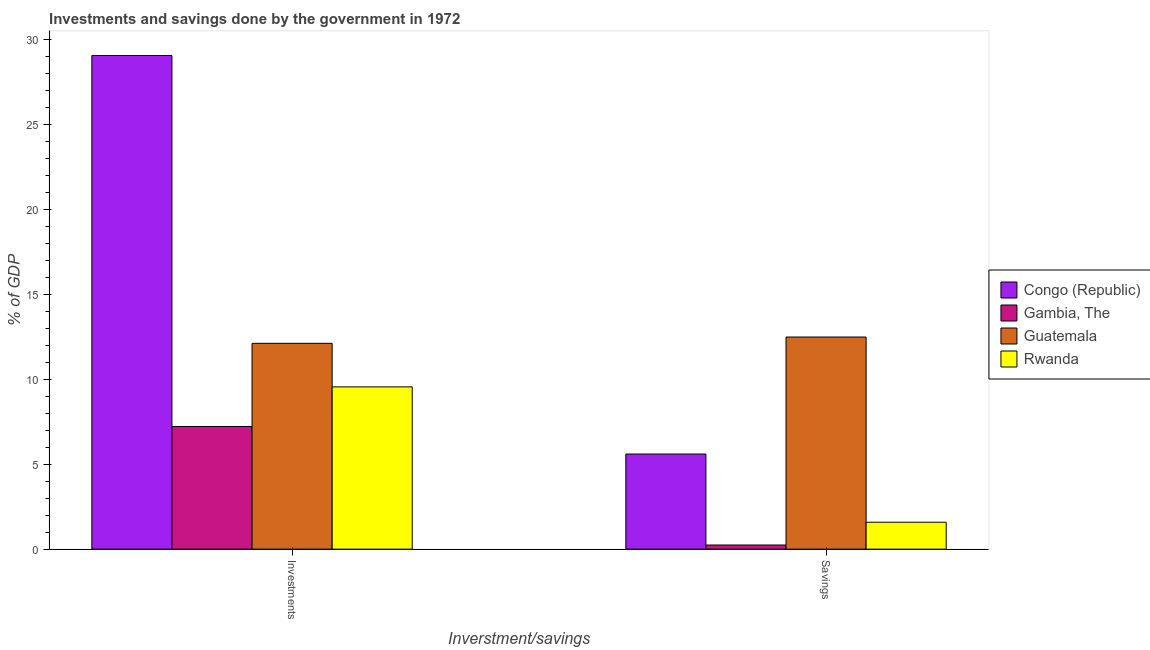How many different coloured bars are there?
Give a very brief answer. 4. How many bars are there on the 1st tick from the left?
Your answer should be very brief. 4. What is the label of the 1st group of bars from the left?
Provide a succinct answer. Investments. What is the savings of government in Gambia, The?
Offer a very short reply. 0.24. Across all countries, what is the maximum savings of government?
Your answer should be compact. 12.5. Across all countries, what is the minimum savings of government?
Keep it short and to the point. 0.24. In which country was the savings of government maximum?
Make the answer very short. Guatemala. In which country was the savings of government minimum?
Provide a succinct answer. Gambia, The. What is the total savings of government in the graph?
Make the answer very short. 19.93. What is the difference between the investments of government in Congo (Republic) and that in Guatemala?
Your answer should be compact. 16.96. What is the difference between the savings of government in Guatemala and the investments of government in Gambia, The?
Keep it short and to the point. 5.27. What is the average savings of government per country?
Make the answer very short. 4.98. What is the difference between the savings of government and investments of government in Rwanda?
Keep it short and to the point. -7.97. In how many countries, is the investments of government greater than 10 %?
Provide a short and direct response. 2. What is the ratio of the investments of government in Congo (Republic) to that in Guatemala?
Make the answer very short. 2.4. In how many countries, is the savings of government greater than the average savings of government taken over all countries?
Your response must be concise. 2. What does the 1st bar from the left in Investments represents?
Provide a succinct answer. Congo (Republic). What does the 3rd bar from the right in Investments represents?
Offer a terse response. Gambia, The. How many bars are there?
Ensure brevity in your answer.  8. How many countries are there in the graph?
Provide a short and direct response. 4. What is the difference between two consecutive major ticks on the Y-axis?
Make the answer very short. 5. Does the graph contain grids?
Offer a very short reply. No. Where does the legend appear in the graph?
Provide a succinct answer. Center right. How are the legend labels stacked?
Provide a succinct answer. Vertical. What is the title of the graph?
Provide a succinct answer. Investments and savings done by the government in 1972. Does "Small states" appear as one of the legend labels in the graph?
Your answer should be compact. No. What is the label or title of the X-axis?
Offer a terse response. Inverstment/savings. What is the label or title of the Y-axis?
Provide a succinct answer. % of GDP. What is the % of GDP of Congo (Republic) in Investments?
Keep it short and to the point. 29.08. What is the % of GDP in Gambia, The in Investments?
Offer a very short reply. 7.23. What is the % of GDP of Guatemala in Investments?
Keep it short and to the point. 12.13. What is the % of GDP of Rwanda in Investments?
Offer a very short reply. 9.56. What is the % of GDP of Congo (Republic) in Savings?
Your answer should be compact. 5.6. What is the % of GDP of Gambia, The in Savings?
Your response must be concise. 0.24. What is the % of GDP of Guatemala in Savings?
Make the answer very short. 12.5. What is the % of GDP of Rwanda in Savings?
Your response must be concise. 1.59. Across all Inverstment/savings, what is the maximum % of GDP in Congo (Republic)?
Your answer should be compact. 29.08. Across all Inverstment/savings, what is the maximum % of GDP in Gambia, The?
Offer a very short reply. 7.23. Across all Inverstment/savings, what is the maximum % of GDP in Guatemala?
Provide a succinct answer. 12.5. Across all Inverstment/savings, what is the maximum % of GDP of Rwanda?
Provide a succinct answer. 9.56. Across all Inverstment/savings, what is the minimum % of GDP of Congo (Republic)?
Your answer should be very brief. 5.6. Across all Inverstment/savings, what is the minimum % of GDP of Gambia, The?
Offer a terse response. 0.24. Across all Inverstment/savings, what is the minimum % of GDP of Guatemala?
Your answer should be very brief. 12.13. Across all Inverstment/savings, what is the minimum % of GDP in Rwanda?
Provide a short and direct response. 1.59. What is the total % of GDP in Congo (Republic) in the graph?
Keep it short and to the point. 34.69. What is the total % of GDP in Gambia, The in the graph?
Your answer should be very brief. 7.47. What is the total % of GDP of Guatemala in the graph?
Make the answer very short. 24.62. What is the total % of GDP of Rwanda in the graph?
Offer a terse response. 11.15. What is the difference between the % of GDP in Congo (Republic) in Investments and that in Savings?
Provide a succinct answer. 23.48. What is the difference between the % of GDP in Gambia, The in Investments and that in Savings?
Your answer should be compact. 6.98. What is the difference between the % of GDP of Guatemala in Investments and that in Savings?
Offer a very short reply. -0.37. What is the difference between the % of GDP in Rwanda in Investments and that in Savings?
Offer a terse response. 7.97. What is the difference between the % of GDP in Congo (Republic) in Investments and the % of GDP in Gambia, The in Savings?
Your answer should be very brief. 28.84. What is the difference between the % of GDP of Congo (Republic) in Investments and the % of GDP of Guatemala in Savings?
Provide a short and direct response. 16.59. What is the difference between the % of GDP of Congo (Republic) in Investments and the % of GDP of Rwanda in Savings?
Your answer should be very brief. 27.5. What is the difference between the % of GDP in Gambia, The in Investments and the % of GDP in Guatemala in Savings?
Your answer should be very brief. -5.27. What is the difference between the % of GDP of Gambia, The in Investments and the % of GDP of Rwanda in Savings?
Provide a short and direct response. 5.64. What is the difference between the % of GDP in Guatemala in Investments and the % of GDP in Rwanda in Savings?
Keep it short and to the point. 10.54. What is the average % of GDP of Congo (Republic) per Inverstment/savings?
Offer a terse response. 17.34. What is the average % of GDP in Gambia, The per Inverstment/savings?
Give a very brief answer. 3.74. What is the average % of GDP in Guatemala per Inverstment/savings?
Provide a short and direct response. 12.31. What is the average % of GDP of Rwanda per Inverstment/savings?
Provide a short and direct response. 5.57. What is the difference between the % of GDP in Congo (Republic) and % of GDP in Gambia, The in Investments?
Give a very brief answer. 21.86. What is the difference between the % of GDP in Congo (Republic) and % of GDP in Guatemala in Investments?
Offer a very short reply. 16.96. What is the difference between the % of GDP in Congo (Republic) and % of GDP in Rwanda in Investments?
Offer a terse response. 19.52. What is the difference between the % of GDP of Gambia, The and % of GDP of Guatemala in Investments?
Make the answer very short. -4.9. What is the difference between the % of GDP in Gambia, The and % of GDP in Rwanda in Investments?
Give a very brief answer. -2.33. What is the difference between the % of GDP in Guatemala and % of GDP in Rwanda in Investments?
Your answer should be compact. 2.57. What is the difference between the % of GDP in Congo (Republic) and % of GDP in Gambia, The in Savings?
Your answer should be very brief. 5.36. What is the difference between the % of GDP of Congo (Republic) and % of GDP of Guatemala in Savings?
Give a very brief answer. -6.89. What is the difference between the % of GDP of Congo (Republic) and % of GDP of Rwanda in Savings?
Provide a short and direct response. 4.02. What is the difference between the % of GDP of Gambia, The and % of GDP of Guatemala in Savings?
Make the answer very short. -12.25. What is the difference between the % of GDP in Gambia, The and % of GDP in Rwanda in Savings?
Give a very brief answer. -1.34. What is the difference between the % of GDP of Guatemala and % of GDP of Rwanda in Savings?
Your answer should be compact. 10.91. What is the ratio of the % of GDP in Congo (Republic) in Investments to that in Savings?
Make the answer very short. 5.19. What is the ratio of the % of GDP of Gambia, The in Investments to that in Savings?
Offer a terse response. 29.63. What is the ratio of the % of GDP in Guatemala in Investments to that in Savings?
Your answer should be very brief. 0.97. What is the ratio of the % of GDP in Rwanda in Investments to that in Savings?
Ensure brevity in your answer.  6.03. What is the difference between the highest and the second highest % of GDP of Congo (Republic)?
Provide a succinct answer. 23.48. What is the difference between the highest and the second highest % of GDP of Gambia, The?
Offer a very short reply. 6.98. What is the difference between the highest and the second highest % of GDP of Guatemala?
Your answer should be very brief. 0.37. What is the difference between the highest and the second highest % of GDP of Rwanda?
Your answer should be compact. 7.97. What is the difference between the highest and the lowest % of GDP in Congo (Republic)?
Your answer should be very brief. 23.48. What is the difference between the highest and the lowest % of GDP in Gambia, The?
Make the answer very short. 6.98. What is the difference between the highest and the lowest % of GDP in Guatemala?
Your response must be concise. 0.37. What is the difference between the highest and the lowest % of GDP in Rwanda?
Ensure brevity in your answer.  7.97. 